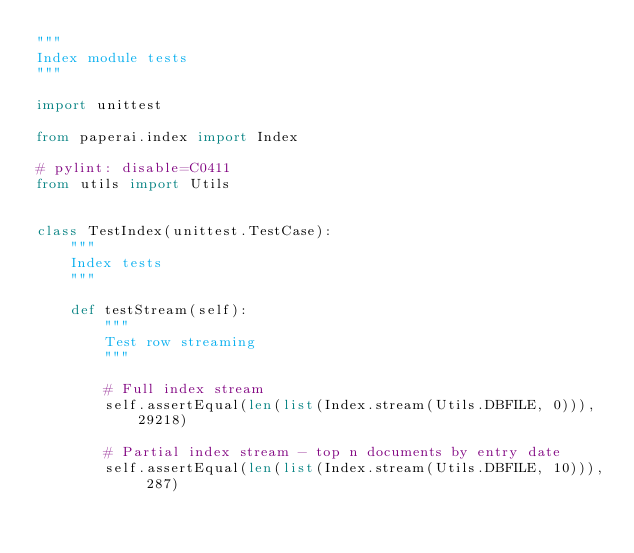<code> <loc_0><loc_0><loc_500><loc_500><_Python_>"""
Index module tests
"""

import unittest

from paperai.index import Index

# pylint: disable=C0411
from utils import Utils


class TestIndex(unittest.TestCase):
    """
    Index tests
    """

    def testStream(self):
        """
        Test row streaming
        """

        # Full index stream
        self.assertEqual(len(list(Index.stream(Utils.DBFILE, 0))), 29218)

        # Partial index stream - top n documents by entry date
        self.assertEqual(len(list(Index.stream(Utils.DBFILE, 10))), 287)
</code> 